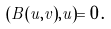<formula> <loc_0><loc_0><loc_500><loc_500>( \tilde { B } ( u , v ) , u ) = 0 \, .</formula> 